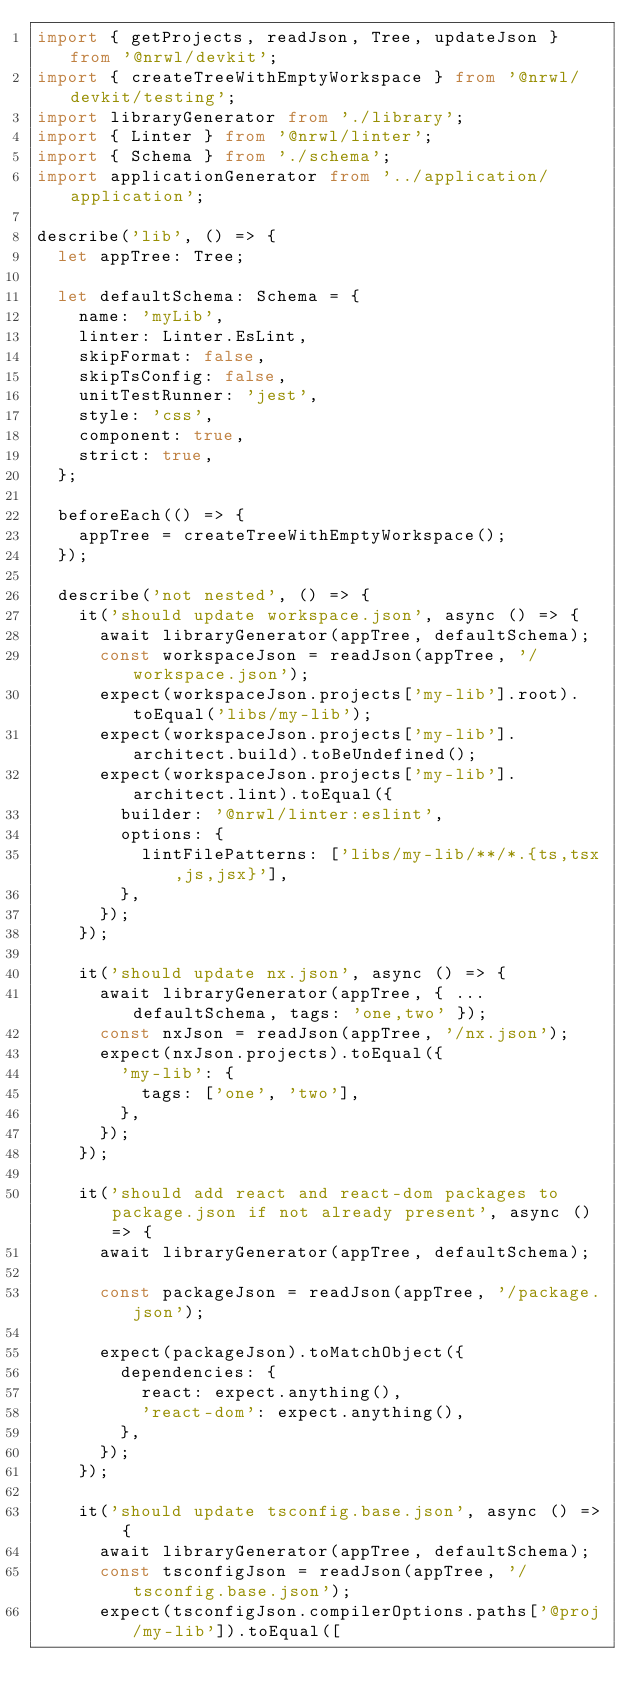<code> <loc_0><loc_0><loc_500><loc_500><_TypeScript_>import { getProjects, readJson, Tree, updateJson } from '@nrwl/devkit';
import { createTreeWithEmptyWorkspace } from '@nrwl/devkit/testing';
import libraryGenerator from './library';
import { Linter } from '@nrwl/linter';
import { Schema } from './schema';
import applicationGenerator from '../application/application';

describe('lib', () => {
  let appTree: Tree;

  let defaultSchema: Schema = {
    name: 'myLib',
    linter: Linter.EsLint,
    skipFormat: false,
    skipTsConfig: false,
    unitTestRunner: 'jest',
    style: 'css',
    component: true,
    strict: true,
  };

  beforeEach(() => {
    appTree = createTreeWithEmptyWorkspace();
  });

  describe('not nested', () => {
    it('should update workspace.json', async () => {
      await libraryGenerator(appTree, defaultSchema);
      const workspaceJson = readJson(appTree, '/workspace.json');
      expect(workspaceJson.projects['my-lib'].root).toEqual('libs/my-lib');
      expect(workspaceJson.projects['my-lib'].architect.build).toBeUndefined();
      expect(workspaceJson.projects['my-lib'].architect.lint).toEqual({
        builder: '@nrwl/linter:eslint',
        options: {
          lintFilePatterns: ['libs/my-lib/**/*.{ts,tsx,js,jsx}'],
        },
      });
    });

    it('should update nx.json', async () => {
      await libraryGenerator(appTree, { ...defaultSchema, tags: 'one,two' });
      const nxJson = readJson(appTree, '/nx.json');
      expect(nxJson.projects).toEqual({
        'my-lib': {
          tags: ['one', 'two'],
        },
      });
    });

    it('should add react and react-dom packages to package.json if not already present', async () => {
      await libraryGenerator(appTree, defaultSchema);

      const packageJson = readJson(appTree, '/package.json');

      expect(packageJson).toMatchObject({
        dependencies: {
          react: expect.anything(),
          'react-dom': expect.anything(),
        },
      });
    });

    it('should update tsconfig.base.json', async () => {
      await libraryGenerator(appTree, defaultSchema);
      const tsconfigJson = readJson(appTree, '/tsconfig.base.json');
      expect(tsconfigJson.compilerOptions.paths['@proj/my-lib']).toEqual([</code> 